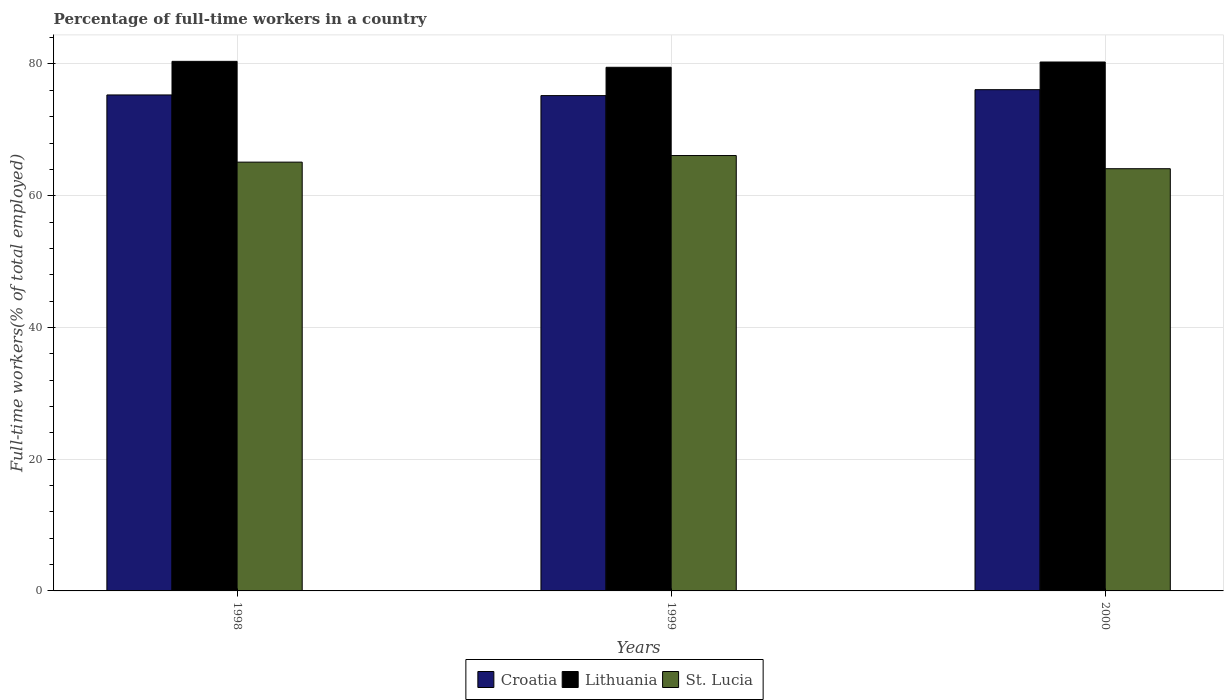How many different coloured bars are there?
Keep it short and to the point. 3. Are the number of bars per tick equal to the number of legend labels?
Your answer should be compact. Yes. Are the number of bars on each tick of the X-axis equal?
Provide a short and direct response. Yes. How many bars are there on the 3rd tick from the left?
Keep it short and to the point. 3. What is the label of the 2nd group of bars from the left?
Offer a terse response. 1999. What is the percentage of full-time workers in St. Lucia in 1999?
Your response must be concise. 66.1. Across all years, what is the maximum percentage of full-time workers in Croatia?
Make the answer very short. 76.1. Across all years, what is the minimum percentage of full-time workers in Lithuania?
Ensure brevity in your answer.  79.5. In which year was the percentage of full-time workers in St. Lucia minimum?
Your answer should be very brief. 2000. What is the total percentage of full-time workers in Lithuania in the graph?
Your answer should be compact. 240.2. What is the difference between the percentage of full-time workers in Croatia in 1998 and that in 1999?
Your answer should be very brief. 0.1. What is the difference between the percentage of full-time workers in Croatia in 2000 and the percentage of full-time workers in Lithuania in 1999?
Your answer should be very brief. -3.4. What is the average percentage of full-time workers in St. Lucia per year?
Offer a very short reply. 65.1. In the year 1999, what is the difference between the percentage of full-time workers in Lithuania and percentage of full-time workers in St. Lucia?
Ensure brevity in your answer.  13.4. In how many years, is the percentage of full-time workers in Croatia greater than 60 %?
Ensure brevity in your answer.  3. What is the ratio of the percentage of full-time workers in Croatia in 1999 to that in 2000?
Your response must be concise. 0.99. Is the percentage of full-time workers in St. Lucia in 1998 less than that in 2000?
Ensure brevity in your answer.  No. Is the difference between the percentage of full-time workers in Lithuania in 1998 and 1999 greater than the difference between the percentage of full-time workers in St. Lucia in 1998 and 1999?
Ensure brevity in your answer.  Yes. What is the difference between the highest and the second highest percentage of full-time workers in Croatia?
Your answer should be very brief. 0.8. What is the difference between the highest and the lowest percentage of full-time workers in Lithuania?
Your response must be concise. 0.9. What does the 2nd bar from the left in 1998 represents?
Offer a terse response. Lithuania. What does the 1st bar from the right in 1999 represents?
Provide a short and direct response. St. Lucia. How many years are there in the graph?
Give a very brief answer. 3. Are the values on the major ticks of Y-axis written in scientific E-notation?
Offer a very short reply. No. Where does the legend appear in the graph?
Your answer should be very brief. Bottom center. How are the legend labels stacked?
Make the answer very short. Horizontal. What is the title of the graph?
Keep it short and to the point. Percentage of full-time workers in a country. What is the label or title of the X-axis?
Offer a terse response. Years. What is the label or title of the Y-axis?
Provide a succinct answer. Full-time workers(% of total employed). What is the Full-time workers(% of total employed) in Croatia in 1998?
Your answer should be very brief. 75.3. What is the Full-time workers(% of total employed) of Lithuania in 1998?
Keep it short and to the point. 80.4. What is the Full-time workers(% of total employed) of St. Lucia in 1998?
Offer a terse response. 65.1. What is the Full-time workers(% of total employed) in Croatia in 1999?
Provide a short and direct response. 75.2. What is the Full-time workers(% of total employed) in Lithuania in 1999?
Ensure brevity in your answer.  79.5. What is the Full-time workers(% of total employed) in St. Lucia in 1999?
Ensure brevity in your answer.  66.1. What is the Full-time workers(% of total employed) of Croatia in 2000?
Offer a very short reply. 76.1. What is the Full-time workers(% of total employed) in Lithuania in 2000?
Provide a succinct answer. 80.3. What is the Full-time workers(% of total employed) of St. Lucia in 2000?
Offer a very short reply. 64.1. Across all years, what is the maximum Full-time workers(% of total employed) of Croatia?
Make the answer very short. 76.1. Across all years, what is the maximum Full-time workers(% of total employed) in Lithuania?
Your answer should be very brief. 80.4. Across all years, what is the maximum Full-time workers(% of total employed) of St. Lucia?
Your response must be concise. 66.1. Across all years, what is the minimum Full-time workers(% of total employed) of Croatia?
Offer a terse response. 75.2. Across all years, what is the minimum Full-time workers(% of total employed) in Lithuania?
Your answer should be very brief. 79.5. Across all years, what is the minimum Full-time workers(% of total employed) in St. Lucia?
Provide a short and direct response. 64.1. What is the total Full-time workers(% of total employed) in Croatia in the graph?
Offer a very short reply. 226.6. What is the total Full-time workers(% of total employed) of Lithuania in the graph?
Your response must be concise. 240.2. What is the total Full-time workers(% of total employed) of St. Lucia in the graph?
Your response must be concise. 195.3. What is the difference between the Full-time workers(% of total employed) in Croatia in 1998 and that in 1999?
Ensure brevity in your answer.  0.1. What is the difference between the Full-time workers(% of total employed) in Lithuania in 1998 and that in 1999?
Your answer should be very brief. 0.9. What is the difference between the Full-time workers(% of total employed) in Croatia in 1999 and that in 2000?
Provide a short and direct response. -0.9. What is the difference between the Full-time workers(% of total employed) in Lithuania in 1999 and that in 2000?
Keep it short and to the point. -0.8. What is the difference between the Full-time workers(% of total employed) of St. Lucia in 1999 and that in 2000?
Offer a very short reply. 2. What is the difference between the Full-time workers(% of total employed) in Croatia in 1998 and the Full-time workers(% of total employed) in Lithuania in 1999?
Offer a very short reply. -4.2. What is the difference between the Full-time workers(% of total employed) of Croatia in 1998 and the Full-time workers(% of total employed) of St. Lucia in 1999?
Your response must be concise. 9.2. What is the difference between the Full-time workers(% of total employed) in Croatia in 1998 and the Full-time workers(% of total employed) in St. Lucia in 2000?
Offer a terse response. 11.2. What is the difference between the Full-time workers(% of total employed) in Lithuania in 1999 and the Full-time workers(% of total employed) in St. Lucia in 2000?
Keep it short and to the point. 15.4. What is the average Full-time workers(% of total employed) of Croatia per year?
Make the answer very short. 75.53. What is the average Full-time workers(% of total employed) of Lithuania per year?
Make the answer very short. 80.07. What is the average Full-time workers(% of total employed) in St. Lucia per year?
Ensure brevity in your answer.  65.1. In the year 1998, what is the difference between the Full-time workers(% of total employed) of Croatia and Full-time workers(% of total employed) of Lithuania?
Offer a very short reply. -5.1. In the year 1998, what is the difference between the Full-time workers(% of total employed) of Lithuania and Full-time workers(% of total employed) of St. Lucia?
Your answer should be very brief. 15.3. In the year 1999, what is the difference between the Full-time workers(% of total employed) of Croatia and Full-time workers(% of total employed) of Lithuania?
Offer a very short reply. -4.3. In the year 2000, what is the difference between the Full-time workers(% of total employed) in Croatia and Full-time workers(% of total employed) in St. Lucia?
Your answer should be very brief. 12. In the year 2000, what is the difference between the Full-time workers(% of total employed) in Lithuania and Full-time workers(% of total employed) in St. Lucia?
Make the answer very short. 16.2. What is the ratio of the Full-time workers(% of total employed) of Croatia in 1998 to that in 1999?
Provide a short and direct response. 1. What is the ratio of the Full-time workers(% of total employed) of Lithuania in 1998 to that in 1999?
Keep it short and to the point. 1.01. What is the ratio of the Full-time workers(% of total employed) in St. Lucia in 1998 to that in 1999?
Make the answer very short. 0.98. What is the ratio of the Full-time workers(% of total employed) in St. Lucia in 1998 to that in 2000?
Offer a terse response. 1.02. What is the ratio of the Full-time workers(% of total employed) of St. Lucia in 1999 to that in 2000?
Your answer should be very brief. 1.03. What is the difference between the highest and the second highest Full-time workers(% of total employed) of Croatia?
Provide a succinct answer. 0.8. What is the difference between the highest and the second highest Full-time workers(% of total employed) in St. Lucia?
Offer a very short reply. 1. What is the difference between the highest and the lowest Full-time workers(% of total employed) in Croatia?
Provide a succinct answer. 0.9. What is the difference between the highest and the lowest Full-time workers(% of total employed) of Lithuania?
Give a very brief answer. 0.9. 